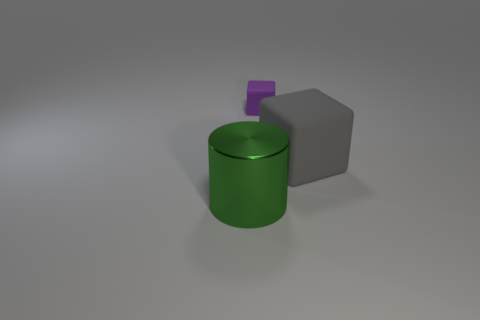If we were to consider the textures in this image, what observations might you make? Observing the texture of the objects, we notice that the green cylinder boasts a reflective surface that hints at a smooth, possibly metallic material, catching the light and displaying a sheen. The gray cube contrasts this with its matte finish, which absorbs the light and suggests a more porous or rough texture. The purple cube, though small, has a similarly shiny finish to the green cylinder, potentially indicating a similar material used in a different hue. 